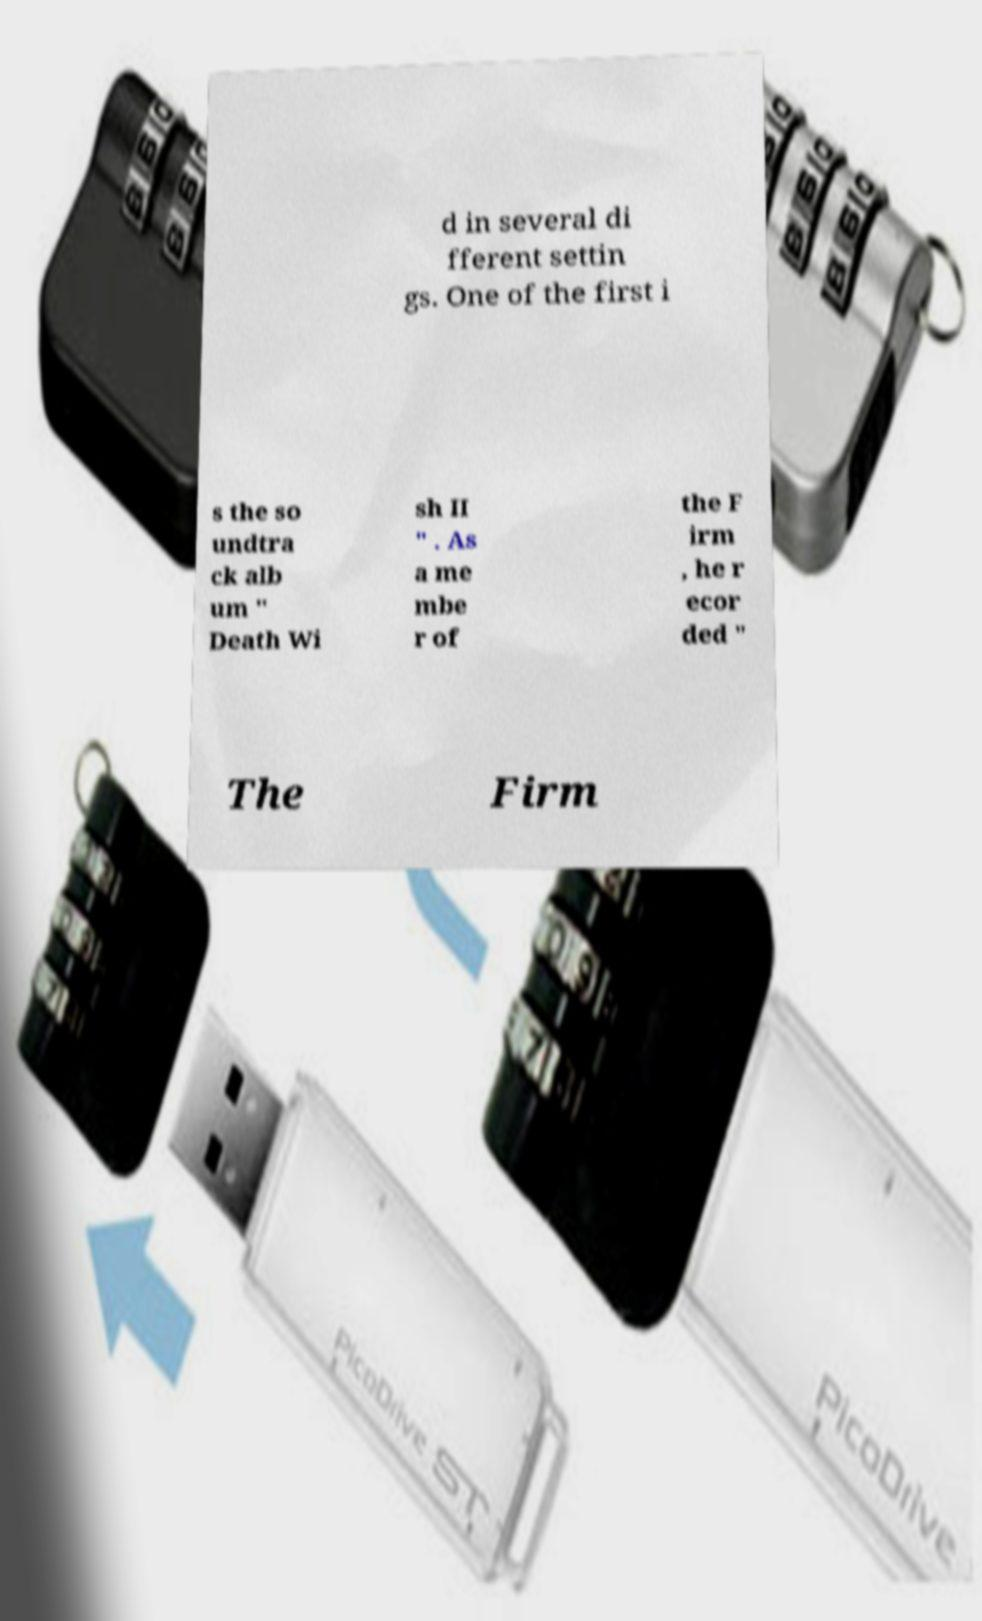Could you assist in decoding the text presented in this image and type it out clearly? d in several di fferent settin gs. One of the first i s the so undtra ck alb um " Death Wi sh II " . As a me mbe r of the F irm , he r ecor ded " The Firm 